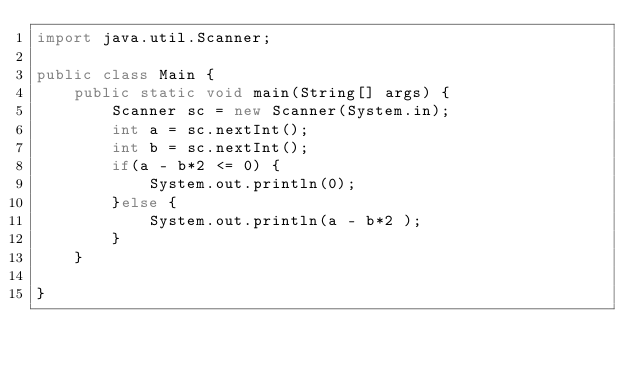Convert code to text. <code><loc_0><loc_0><loc_500><loc_500><_Java_>import java.util.Scanner;
 
public class Main {
	public static void main(String[] args) {
	    Scanner sc = new Scanner(System.in);
	    int a = sc.nextInt();
	    int b = sc.nextInt();
	    if(a - b*2 <= 0) {
	        System.out.println(0);
	    }else {
	        System.out.println(a - b*2 );
	    }
	}
	
}</code> 